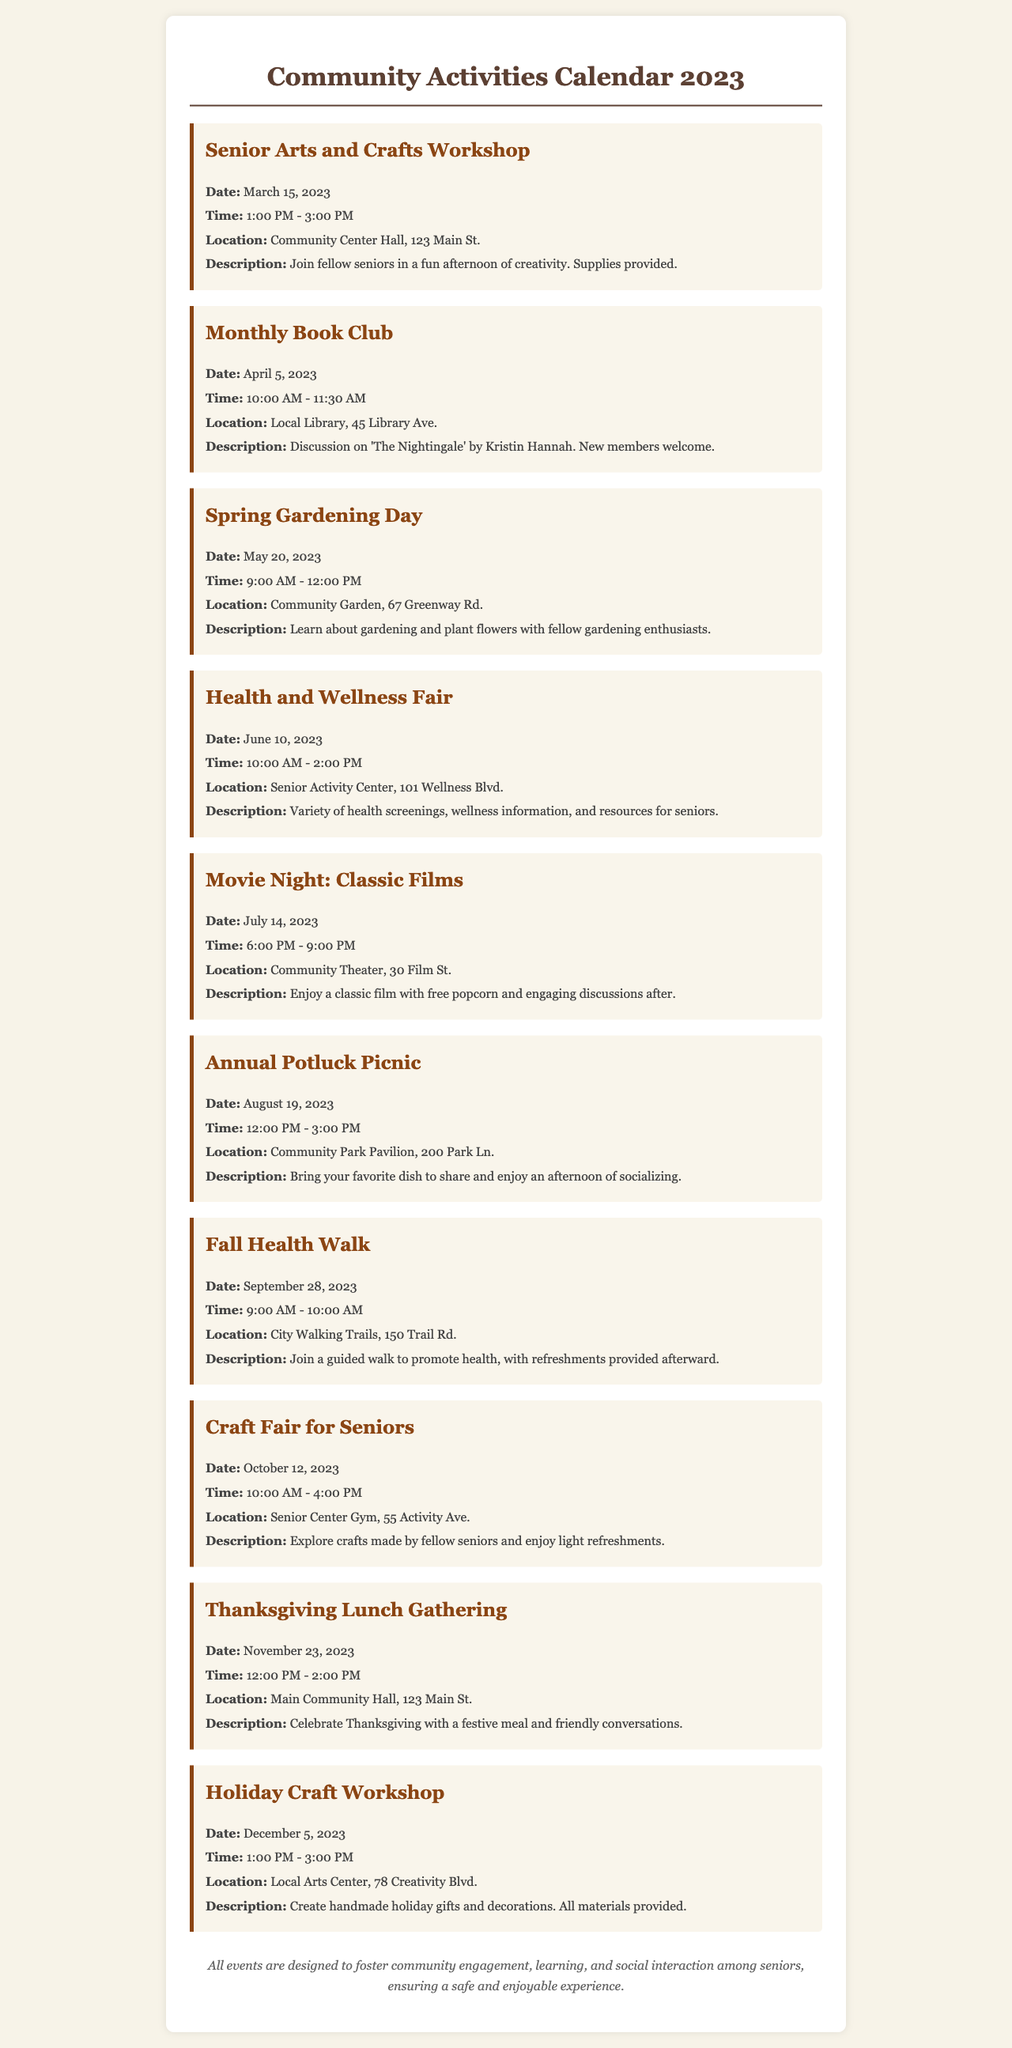What is the title of the first event? The first event is labeled with the title "Senior Arts and Crafts Workshop" in the document.
Answer: Senior Arts and Crafts Workshop When is the Health and Wellness Fair scheduled? The date noted for the Health and Wellness Fair is June 10, 2023, as mentioned in the document.
Answer: June 10, 2023 Where will the Thanksgiving Lunch Gathering be held? The location specified for the Thanksgiving Lunch Gathering is "Main Community Hall, 123 Main St."
Answer: Main Community Hall, 123 Main St How long is the Movie Night event? The Movie Night event is scheduled from 6:00 PM to 9:00 PM, which totals three hours.
Answer: 3 hours Which event occurs in April? The event taking place in April is the "Monthly Book Club" according to the event listings.
Answer: Monthly Book Club What is provided at the Holiday Craft Workshop? The document mentions that "All materials provided" for creating handmade holiday gifts and decorations.
Answer: All materials provided How many events are scheduled for the month of August? There is one event scheduled for August 19, 2023, which is the Annual Potluck Picnic, as stated in the calendar.
Answer: 1 What is the main purpose of these community events? The document notes that all events aim to foster community engagement, learning, and social interaction among seniors.
Answer: Foster community engagement What type of gathering is planned for November? The event planned for November is a "Thanksgiving Lunch Gathering," which indicates a festive meal atmosphere.
Answer: Thanksgiving Lunch Gathering 